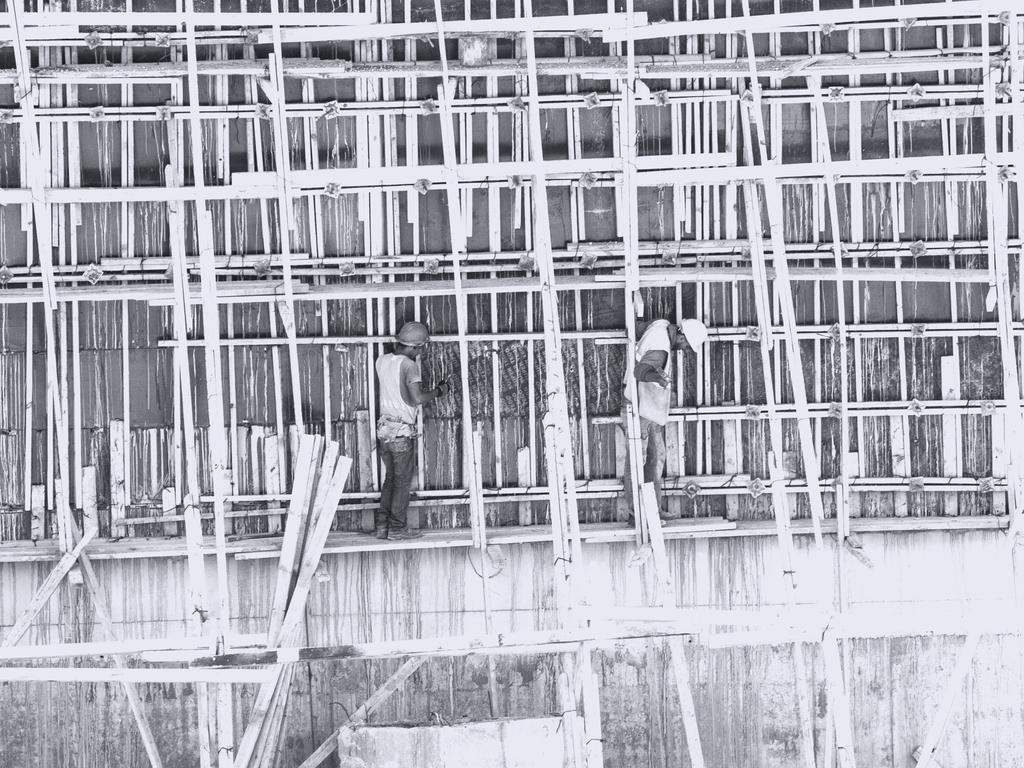Could you give a brief overview of what you see in this image? It looks like a black and white picture. We can see there are two people standing on a wooden object and behind the people there are wooden objects and a wall. 